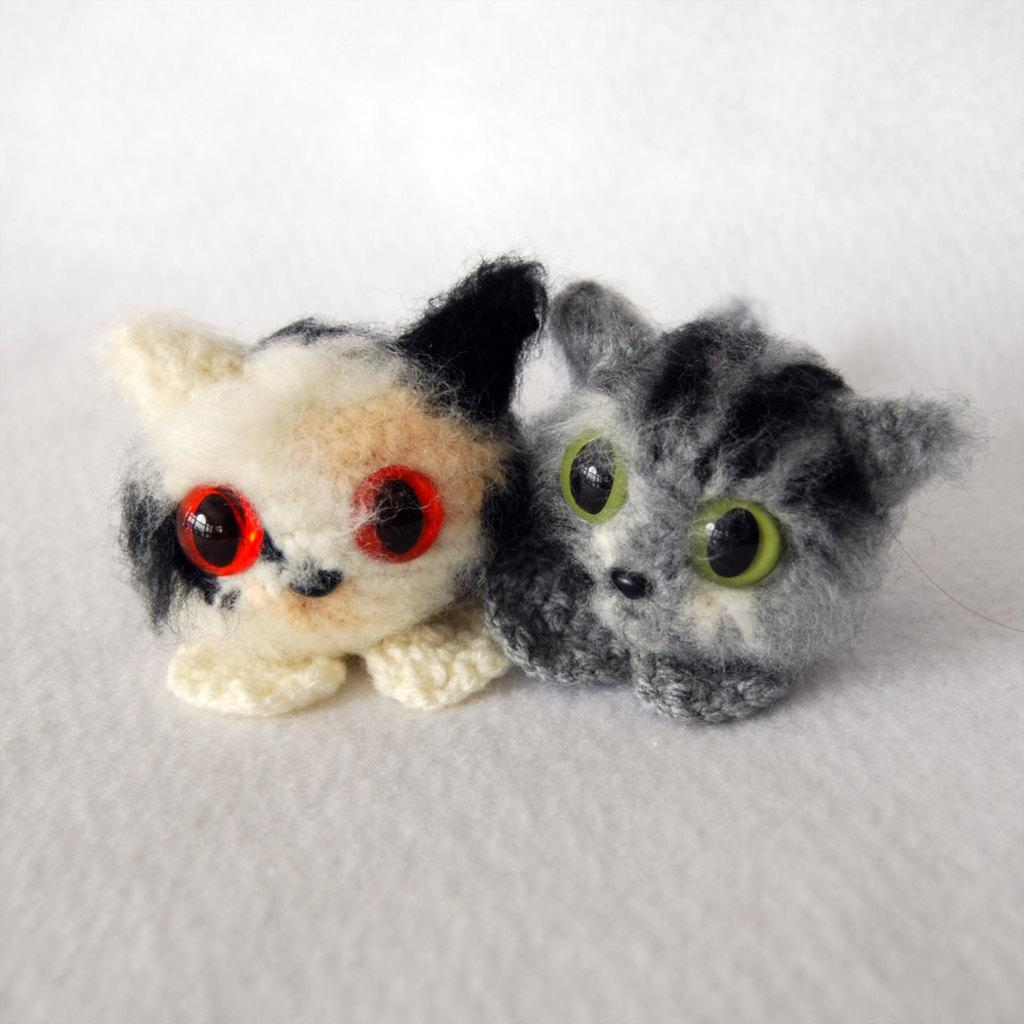How many toys can be seen in the image? There are two toys in the image. What can be observed about the background of the image? The background of the image is white in color. How many pizzas are being served at the swimming pool in the image? There are no pizzas or swimming pools present in the image. 